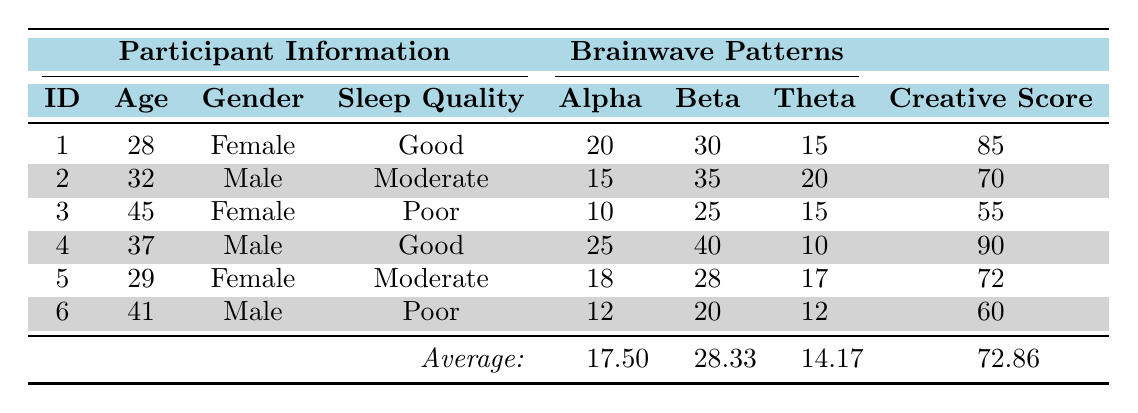What is the Creative Ideation Score of participant ID 3? Looking at the table, I can find participant ID 3's row and see that the Creative Ideation Score is listed as 55.
Answer: 55 What is the average age of all participants? The ages of the participants are 28, 32, 45, 37, 29, and 41. Adding these gives a total of 28 + 32 + 45 + 37 + 29 + 41 = 212. There are 6 participants, so the average age is 212/6 = 35.33.
Answer: 35.33 How many participants had a Good Sleep Quality? Referring to the table, I can see that participants ID 1 and ID 4 have Good Sleep Quality, making a total of 2 participants.
Answer: 2 What is the highest Creative Ideation Score and which participant achieved it? Scanning through the Creative Ideation Scores, the highest score is 90, which belongs to participant ID 4.
Answer: 90, participant ID 4 Is there a participant with a Poor Sleep Quality who has a Creative Ideation Score above 60? Participant ID 6 has Poor Sleep Quality with a Creative Ideation Score of 60, while participant ID 3 also has Poor Sleep Quality with a score of 55. Since both scores are not above 60, the answer is no.
Answer: No What is the difference in Creative Ideation Scores between the participants with Good sleep quality and those with Poor sleep quality? Participant with Good Sleep Quality have scores of 85 and 90, averaging to (85 + 90) / 2 = 87.5. For Poor Sleep Quality, the scores are 60 and 55, averaging to (60 + 55) / 2 = 57.5. The difference is 87.5 - 57.5 = 30.
Answer: 30 What is the average Alpha brainwave value for all participants? The Alpha values are 20, 15, 10, 25, 18, and 12. Summing these yields 20 + 15 + 10 + 25 + 18 + 12 = 110. With 6 participants, the average Alpha is 110 / 6 = 18.33.
Answer: 18.33 Did the participant with the highest Beta value have Good Sleep Quality? Participant ID 4 has the highest Beta value at 40, and according to the table, ID 4 has Good Sleep Quality. Thus, the answer is yes.
Answer: Yes What is the total Creative Ideation Score of participants with Moderate Sleep Quality? The scores for Moderate Sleep Quality are 70 (ID 2) and 72 (ID 5). Adding these gives a total of 70 + 72 = 142.
Answer: 142 Calculate the average Theta brainwave value for participants with a Good Sleep Quality. Participant ID 1 has a Theta of 15, and ID 4 has a Theta of 10. The average is (15 + 10) / 2 = 12.5.
Answer: 12.5 